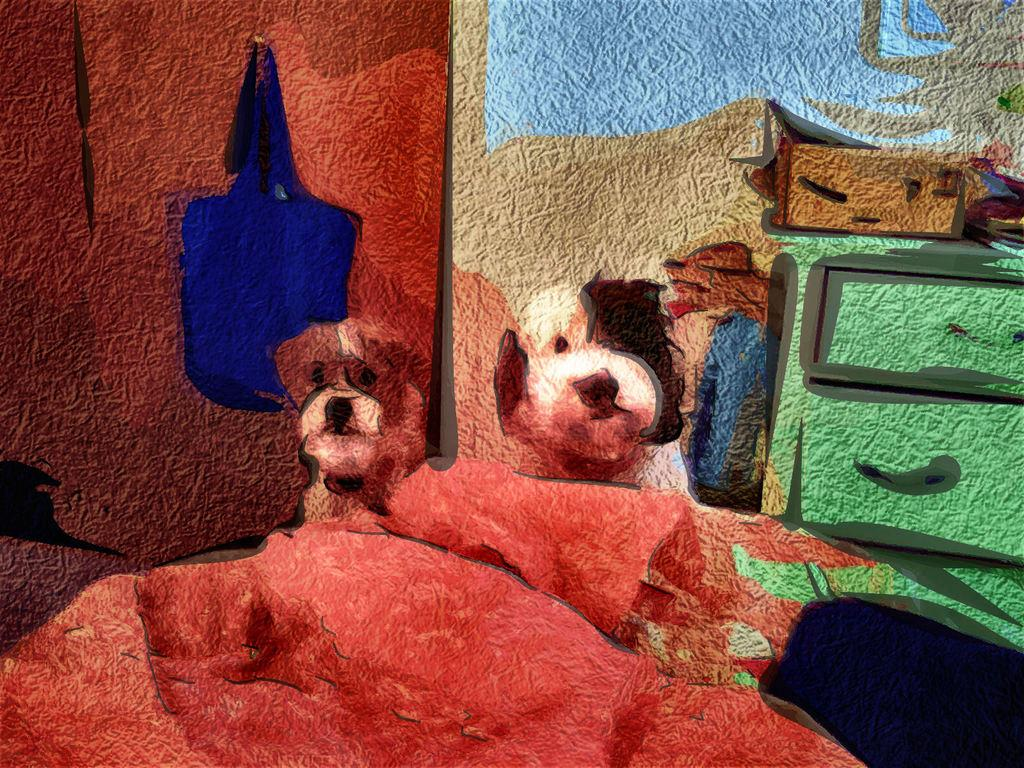What type of artwork is visible in the image? There are colorful paintings in the image. What subjects are depicted in the paintings? The paintings depict animals and other objects, such as a bag. Where are the paintings located in the image? The paintings appear to be on a wall, suggesting it is a wall painting. What type of hat is hanging on the curtain in the image? There is no hat or curtain present in the image; it features colorful paintings on a wall. Can you describe the plane that is flying in the image? There is no plane visible in the image; it only contains colorful paintings depicting animals and other objects. 